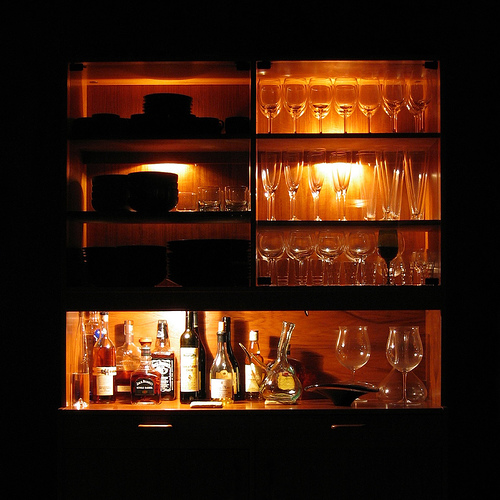<image>
Can you confirm if the glass is to the left of the glass? No. The glass is not to the left of the glass. From this viewpoint, they have a different horizontal relationship. 